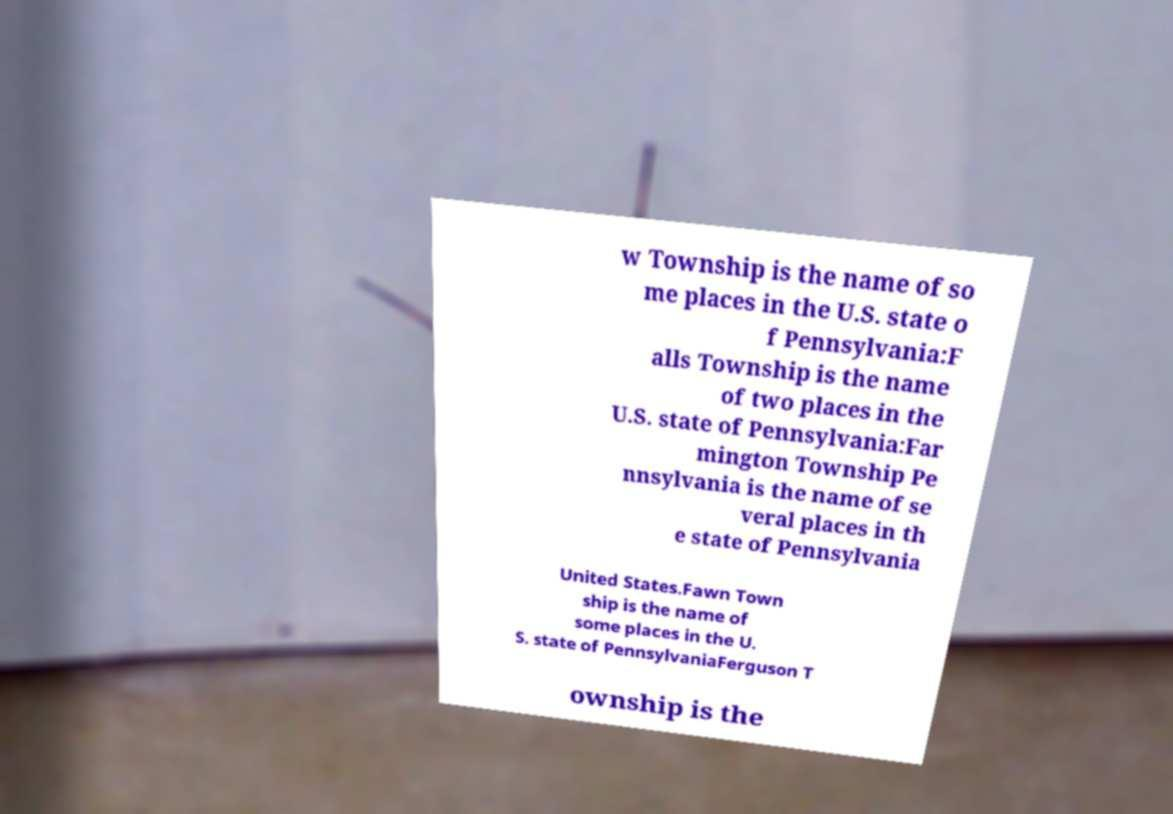I need the written content from this picture converted into text. Can you do that? w Township is the name of so me places in the U.S. state o f Pennsylvania:F alls Township is the name of two places in the U.S. state of Pennsylvania:Far mington Township Pe nnsylvania is the name of se veral places in th e state of Pennsylvania United States.Fawn Town ship is the name of some places in the U. S. state of PennsylvaniaFerguson T ownship is the 